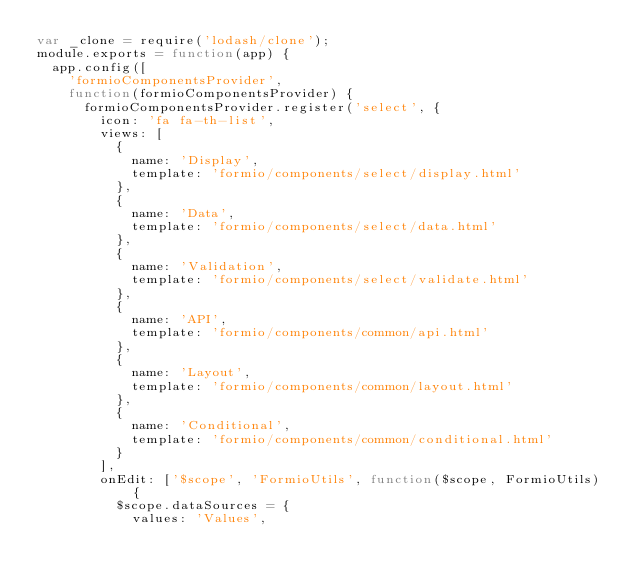Convert code to text. <code><loc_0><loc_0><loc_500><loc_500><_JavaScript_>var _clone = require('lodash/clone');
module.exports = function(app) {
  app.config([
    'formioComponentsProvider',
    function(formioComponentsProvider) {
      formioComponentsProvider.register('select', {
        icon: 'fa fa-th-list',
        views: [
          {
            name: 'Display',
            template: 'formio/components/select/display.html'
          },
          {
            name: 'Data',
            template: 'formio/components/select/data.html'
          },
          {
            name: 'Validation',
            template: 'formio/components/select/validate.html'
          },
          {
            name: 'API',
            template: 'formio/components/common/api.html'
          },
          {
            name: 'Layout',
            template: 'formio/components/common/layout.html'
          },
          {
            name: 'Conditional',
            template: 'formio/components/common/conditional.html'
          }
        ],
        onEdit: ['$scope', 'FormioUtils', function($scope, FormioUtils) {
          $scope.dataSources = {
            values: 'Values',</code> 